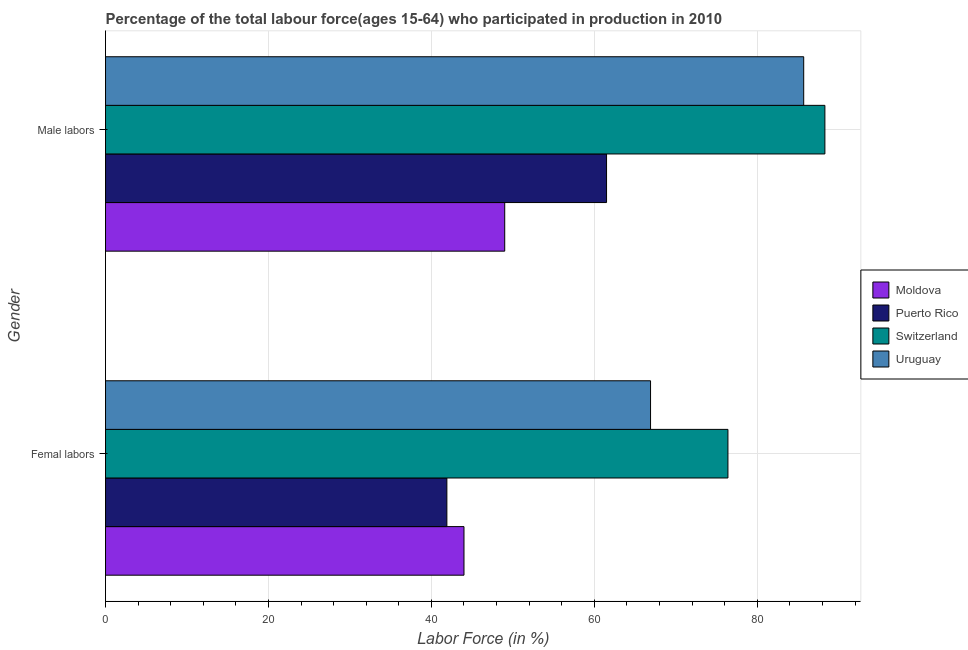How many groups of bars are there?
Provide a short and direct response. 2. Are the number of bars per tick equal to the number of legend labels?
Give a very brief answer. Yes. What is the label of the 1st group of bars from the top?
Offer a terse response. Male labors. What is the percentage of female labor force in Switzerland?
Keep it short and to the point. 76.4. Across all countries, what is the maximum percentage of male labour force?
Make the answer very short. 88.3. Across all countries, what is the minimum percentage of female labor force?
Ensure brevity in your answer.  41.9. In which country was the percentage of male labour force maximum?
Your response must be concise. Switzerland. In which country was the percentage of male labour force minimum?
Ensure brevity in your answer.  Moldova. What is the total percentage of female labor force in the graph?
Offer a very short reply. 229.2. What is the difference between the percentage of male labour force in Moldova and that in Switzerland?
Your answer should be very brief. -39.3. What is the difference between the percentage of male labour force in Moldova and the percentage of female labor force in Uruguay?
Offer a very short reply. -17.9. What is the average percentage of female labor force per country?
Make the answer very short. 57.3. What is the difference between the percentage of male labour force and percentage of female labor force in Uruguay?
Keep it short and to the point. 18.8. In how many countries, is the percentage of female labor force greater than 76 %?
Offer a terse response. 1. What is the ratio of the percentage of male labour force in Moldova to that in Puerto Rico?
Provide a short and direct response. 0.8. Is the percentage of female labor force in Moldova less than that in Switzerland?
Provide a short and direct response. Yes. In how many countries, is the percentage of male labour force greater than the average percentage of male labour force taken over all countries?
Ensure brevity in your answer.  2. What does the 2nd bar from the top in Male labors represents?
Give a very brief answer. Switzerland. What does the 2nd bar from the bottom in Male labors represents?
Make the answer very short. Puerto Rico. Does the graph contain any zero values?
Provide a succinct answer. No. Where does the legend appear in the graph?
Make the answer very short. Center right. What is the title of the graph?
Keep it short and to the point. Percentage of the total labour force(ages 15-64) who participated in production in 2010. What is the label or title of the X-axis?
Provide a succinct answer. Labor Force (in %). What is the Labor Force (in %) of Puerto Rico in Femal labors?
Ensure brevity in your answer.  41.9. What is the Labor Force (in %) in Switzerland in Femal labors?
Your response must be concise. 76.4. What is the Labor Force (in %) of Uruguay in Femal labors?
Ensure brevity in your answer.  66.9. What is the Labor Force (in %) of Moldova in Male labors?
Keep it short and to the point. 49. What is the Labor Force (in %) of Puerto Rico in Male labors?
Your response must be concise. 61.5. What is the Labor Force (in %) of Switzerland in Male labors?
Your answer should be very brief. 88.3. What is the Labor Force (in %) of Uruguay in Male labors?
Offer a terse response. 85.7. Across all Gender, what is the maximum Labor Force (in %) in Puerto Rico?
Provide a short and direct response. 61.5. Across all Gender, what is the maximum Labor Force (in %) of Switzerland?
Your response must be concise. 88.3. Across all Gender, what is the maximum Labor Force (in %) in Uruguay?
Offer a terse response. 85.7. Across all Gender, what is the minimum Labor Force (in %) of Puerto Rico?
Give a very brief answer. 41.9. Across all Gender, what is the minimum Labor Force (in %) in Switzerland?
Ensure brevity in your answer.  76.4. Across all Gender, what is the minimum Labor Force (in %) in Uruguay?
Give a very brief answer. 66.9. What is the total Labor Force (in %) in Moldova in the graph?
Make the answer very short. 93. What is the total Labor Force (in %) of Puerto Rico in the graph?
Your response must be concise. 103.4. What is the total Labor Force (in %) of Switzerland in the graph?
Provide a succinct answer. 164.7. What is the total Labor Force (in %) of Uruguay in the graph?
Your answer should be compact. 152.6. What is the difference between the Labor Force (in %) of Puerto Rico in Femal labors and that in Male labors?
Provide a succinct answer. -19.6. What is the difference between the Labor Force (in %) in Uruguay in Femal labors and that in Male labors?
Offer a very short reply. -18.8. What is the difference between the Labor Force (in %) of Moldova in Femal labors and the Labor Force (in %) of Puerto Rico in Male labors?
Keep it short and to the point. -17.5. What is the difference between the Labor Force (in %) of Moldova in Femal labors and the Labor Force (in %) of Switzerland in Male labors?
Provide a short and direct response. -44.3. What is the difference between the Labor Force (in %) in Moldova in Femal labors and the Labor Force (in %) in Uruguay in Male labors?
Keep it short and to the point. -41.7. What is the difference between the Labor Force (in %) of Puerto Rico in Femal labors and the Labor Force (in %) of Switzerland in Male labors?
Make the answer very short. -46.4. What is the difference between the Labor Force (in %) in Puerto Rico in Femal labors and the Labor Force (in %) in Uruguay in Male labors?
Make the answer very short. -43.8. What is the average Labor Force (in %) of Moldova per Gender?
Keep it short and to the point. 46.5. What is the average Labor Force (in %) in Puerto Rico per Gender?
Provide a short and direct response. 51.7. What is the average Labor Force (in %) in Switzerland per Gender?
Keep it short and to the point. 82.35. What is the average Labor Force (in %) of Uruguay per Gender?
Offer a very short reply. 76.3. What is the difference between the Labor Force (in %) of Moldova and Labor Force (in %) of Puerto Rico in Femal labors?
Ensure brevity in your answer.  2.1. What is the difference between the Labor Force (in %) of Moldova and Labor Force (in %) of Switzerland in Femal labors?
Provide a succinct answer. -32.4. What is the difference between the Labor Force (in %) in Moldova and Labor Force (in %) in Uruguay in Femal labors?
Offer a very short reply. -22.9. What is the difference between the Labor Force (in %) of Puerto Rico and Labor Force (in %) of Switzerland in Femal labors?
Your answer should be very brief. -34.5. What is the difference between the Labor Force (in %) in Moldova and Labor Force (in %) in Switzerland in Male labors?
Provide a short and direct response. -39.3. What is the difference between the Labor Force (in %) in Moldova and Labor Force (in %) in Uruguay in Male labors?
Ensure brevity in your answer.  -36.7. What is the difference between the Labor Force (in %) of Puerto Rico and Labor Force (in %) of Switzerland in Male labors?
Offer a very short reply. -26.8. What is the difference between the Labor Force (in %) in Puerto Rico and Labor Force (in %) in Uruguay in Male labors?
Provide a succinct answer. -24.2. What is the ratio of the Labor Force (in %) of Moldova in Femal labors to that in Male labors?
Your answer should be compact. 0.9. What is the ratio of the Labor Force (in %) in Puerto Rico in Femal labors to that in Male labors?
Make the answer very short. 0.68. What is the ratio of the Labor Force (in %) of Switzerland in Femal labors to that in Male labors?
Provide a short and direct response. 0.87. What is the ratio of the Labor Force (in %) of Uruguay in Femal labors to that in Male labors?
Provide a succinct answer. 0.78. What is the difference between the highest and the second highest Labor Force (in %) of Puerto Rico?
Give a very brief answer. 19.6. What is the difference between the highest and the second highest Labor Force (in %) of Uruguay?
Ensure brevity in your answer.  18.8. What is the difference between the highest and the lowest Labor Force (in %) of Puerto Rico?
Ensure brevity in your answer.  19.6. 